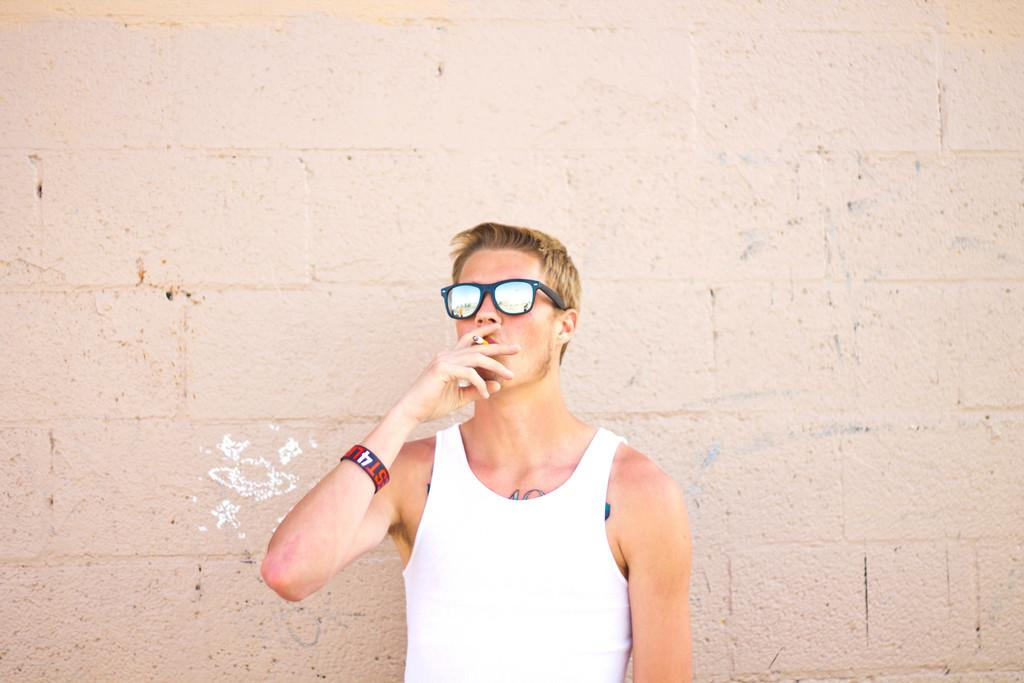What is present in the image? There is a person in the image. What is the person doing in the image? The person is holding an object in his hand and standing. What can be seen in the background of the image? There is a wall in the background of the image. What type of dirt can be seen on the person's shoes in the image? There is no dirt visible on the person's shoes in the image. What does the person believe about the object he is holding in the image? The image does not provide any information about the person's beliefs or thoughts regarding the object he is holding. 